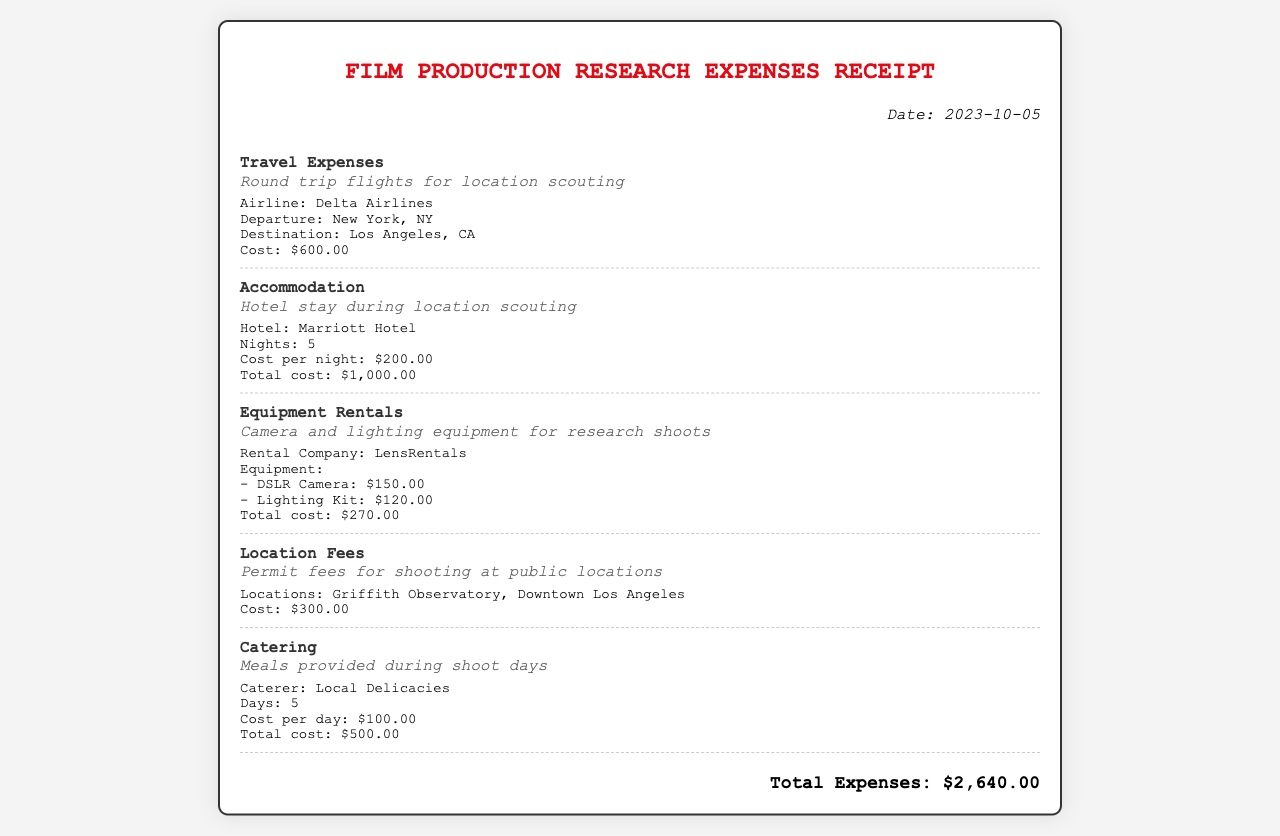What is the date of the receipt? The date of the receipt is mentioned at the top right of the document.
Answer: 2023-10-05 What is the cost of travel expenses? The travel expenses item lists the cost directly within its details.
Answer: $600.00 Which airline was used for the flights? The airline information can be found within the travel expenses section.
Answer: Delta Airlines What is the total cost for accommodation? The accommodation section provides a breakdown of the costs and totals it.
Answer: $1,000.00 How much was spent on equipment rentals? The total cost for equipment rentals is specified in that section.
Answer: $270.00 What locations were mentioned for location fees? The location fees section lists the specific locations in its details.
Answer: Griffith Observatory, Downtown Los Angeles What was the total cost for catering? The catering section provides the total cost clearly stated at the end of its details.
Answer: $500.00 What is the grand total of all expenses? The total expenses figure is displayed prominently at the bottom of the receipt.
Answer: $2,640.00 How many nights was accommodation booked? The number of nights is mentioned in the accommodation item details.
Answer: 5 